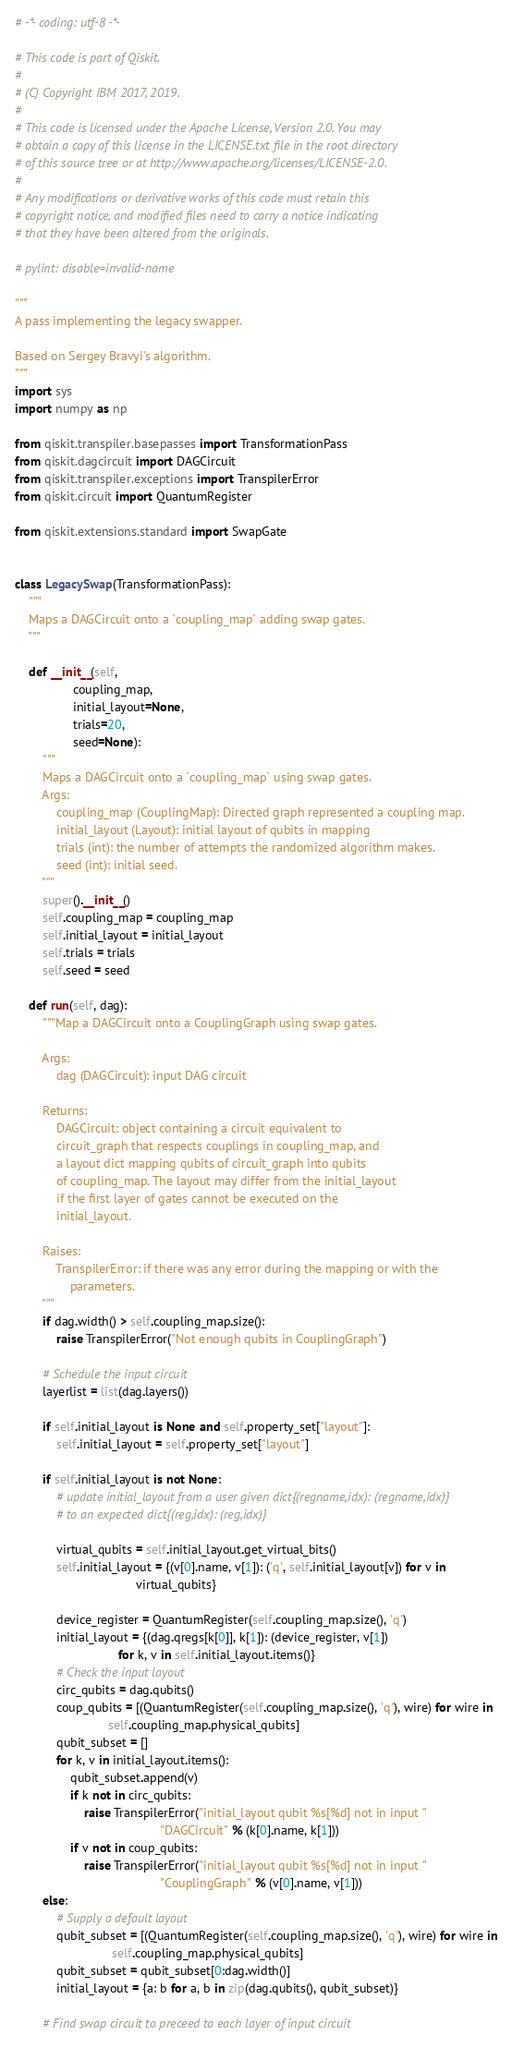<code> <loc_0><loc_0><loc_500><loc_500><_Python_># -*- coding: utf-8 -*-

# This code is part of Qiskit.
#
# (C) Copyright IBM 2017, 2019.
#
# This code is licensed under the Apache License, Version 2.0. You may
# obtain a copy of this license in the LICENSE.txt file in the root directory
# of this source tree or at http://www.apache.org/licenses/LICENSE-2.0.
#
# Any modifications or derivative works of this code must retain this
# copyright notice, and modified files need to carry a notice indicating
# that they have been altered from the originals.

# pylint: disable=invalid-name

"""
A pass implementing the legacy swapper.

Based on Sergey Bravyi's algorithm.
"""
import sys
import numpy as np

from qiskit.transpiler.basepasses import TransformationPass
from qiskit.dagcircuit import DAGCircuit
from qiskit.transpiler.exceptions import TranspilerError
from qiskit.circuit import QuantumRegister

from qiskit.extensions.standard import SwapGate


class LegacySwap(TransformationPass):
    """
    Maps a DAGCircuit onto a `coupling_map` adding swap gates.
    """

    def __init__(self,
                 coupling_map,
                 initial_layout=None,
                 trials=20,
                 seed=None):
        """
        Maps a DAGCircuit onto a `coupling_map` using swap gates.
        Args:
            coupling_map (CouplingMap): Directed graph represented a coupling map.
            initial_layout (Layout): initial layout of qubits in mapping
            trials (int): the number of attempts the randomized algorithm makes.
            seed (int): initial seed.
        """
        super().__init__()
        self.coupling_map = coupling_map
        self.initial_layout = initial_layout
        self.trials = trials
        self.seed = seed

    def run(self, dag):
        """Map a DAGCircuit onto a CouplingGraph using swap gates.

        Args:
            dag (DAGCircuit): input DAG circuit

        Returns:
            DAGCircuit: object containing a circuit equivalent to
            circuit_graph that respects couplings in coupling_map, and
            a layout dict mapping qubits of circuit_graph into qubits
            of coupling_map. The layout may differ from the initial_layout
            if the first layer of gates cannot be executed on the
            initial_layout.

        Raises:
            TranspilerError: if there was any error during the mapping or with the
                parameters.
        """
        if dag.width() > self.coupling_map.size():
            raise TranspilerError("Not enough qubits in CouplingGraph")

        # Schedule the input circuit
        layerlist = list(dag.layers())

        if self.initial_layout is None and self.property_set["layout"]:
            self.initial_layout = self.property_set["layout"]

        if self.initial_layout is not None:
            # update initial_layout from a user given dict{(regname,idx): (regname,idx)}
            # to an expected dict{(reg,idx): (reg,idx)}

            virtual_qubits = self.initial_layout.get_virtual_bits()
            self.initial_layout = {(v[0].name, v[1]): ('q', self.initial_layout[v]) for v in
                                   virtual_qubits}

            device_register = QuantumRegister(self.coupling_map.size(), 'q')
            initial_layout = {(dag.qregs[k[0]], k[1]): (device_register, v[1])
                              for k, v in self.initial_layout.items()}
            # Check the input layout
            circ_qubits = dag.qubits()
            coup_qubits = [(QuantumRegister(self.coupling_map.size(), 'q'), wire) for wire in
                           self.coupling_map.physical_qubits]
            qubit_subset = []
            for k, v in initial_layout.items():
                qubit_subset.append(v)
                if k not in circ_qubits:
                    raise TranspilerError("initial_layout qubit %s[%d] not in input "
                                          "DAGCircuit" % (k[0].name, k[1]))
                if v not in coup_qubits:
                    raise TranspilerError("initial_layout qubit %s[%d] not in input "
                                          "CouplingGraph" % (v[0].name, v[1]))
        else:
            # Supply a default layout
            qubit_subset = [(QuantumRegister(self.coupling_map.size(), 'q'), wire) for wire in
                            self.coupling_map.physical_qubits]
            qubit_subset = qubit_subset[0:dag.width()]
            initial_layout = {a: b for a, b in zip(dag.qubits(), qubit_subset)}

        # Find swap circuit to preceed to each layer of input circuit</code> 